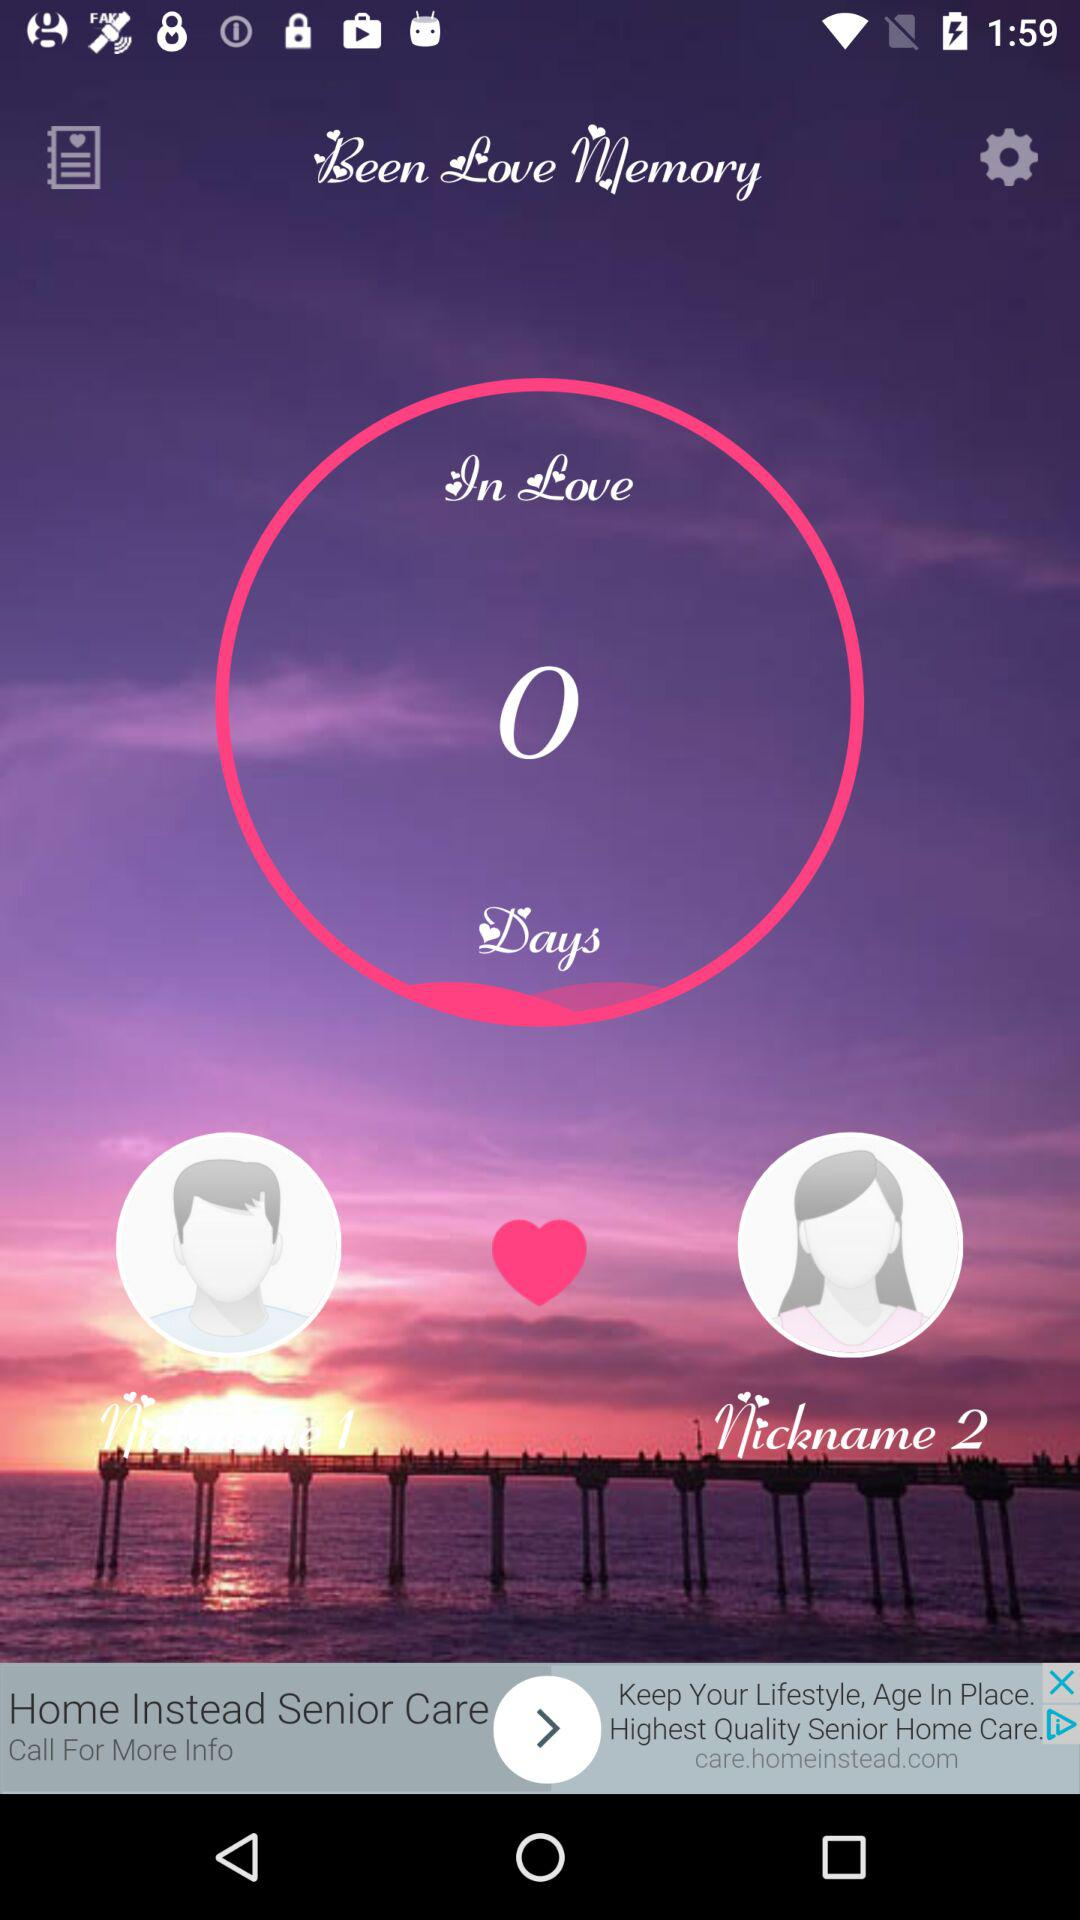What is the application name? The application name is Been Love Memory. 